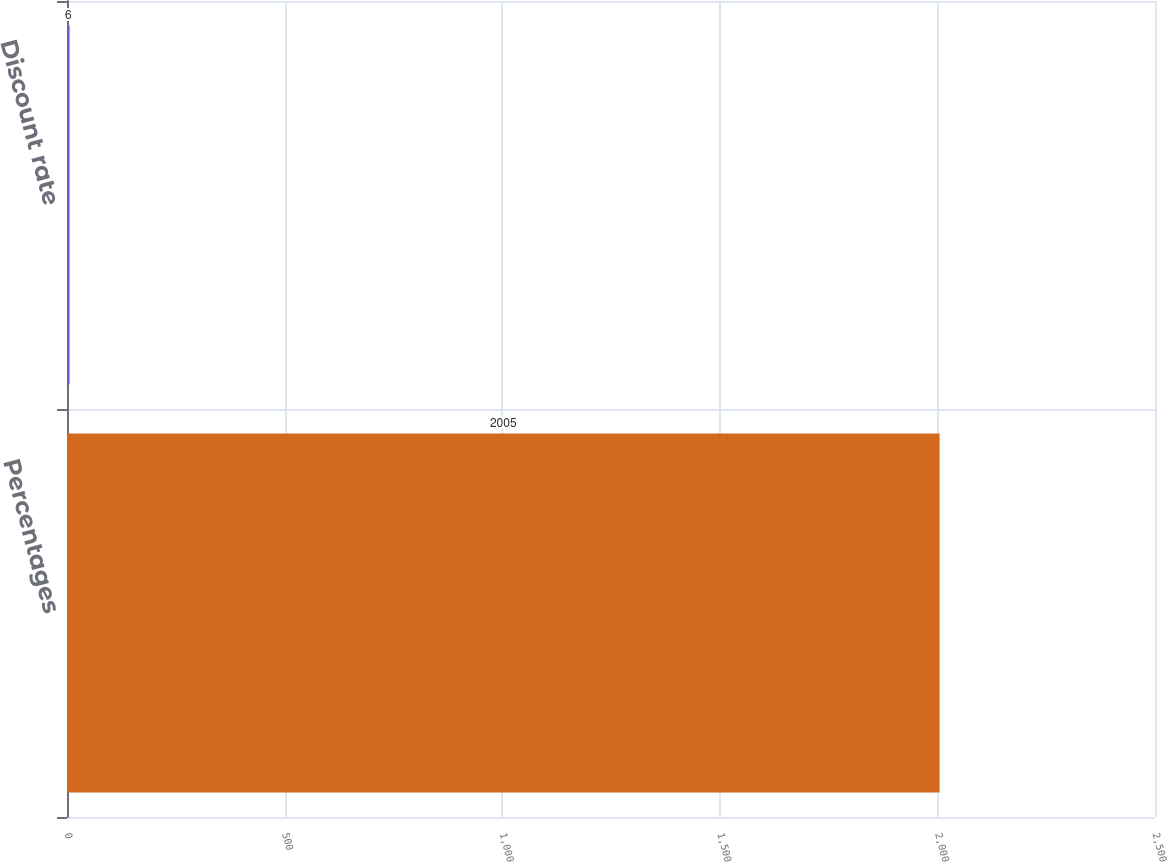Convert chart to OTSL. <chart><loc_0><loc_0><loc_500><loc_500><bar_chart><fcel>Percentages<fcel>Discount rate<nl><fcel>2005<fcel>6<nl></chart> 